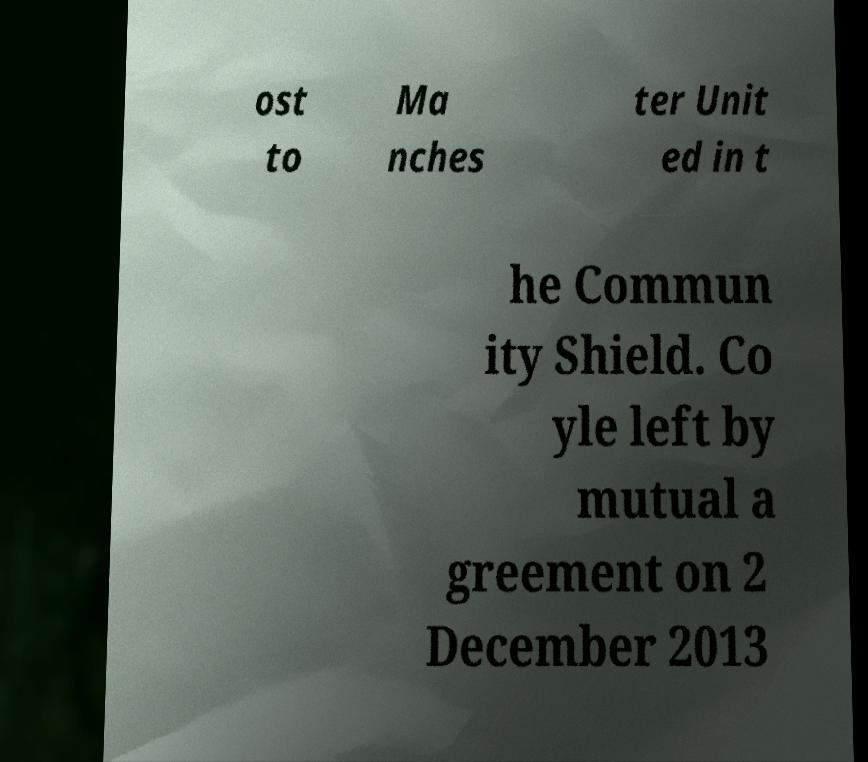Please read and relay the text visible in this image. What does it say? ost to Ma nches ter Unit ed in t he Commun ity Shield. Co yle left by mutual a greement on 2 December 2013 